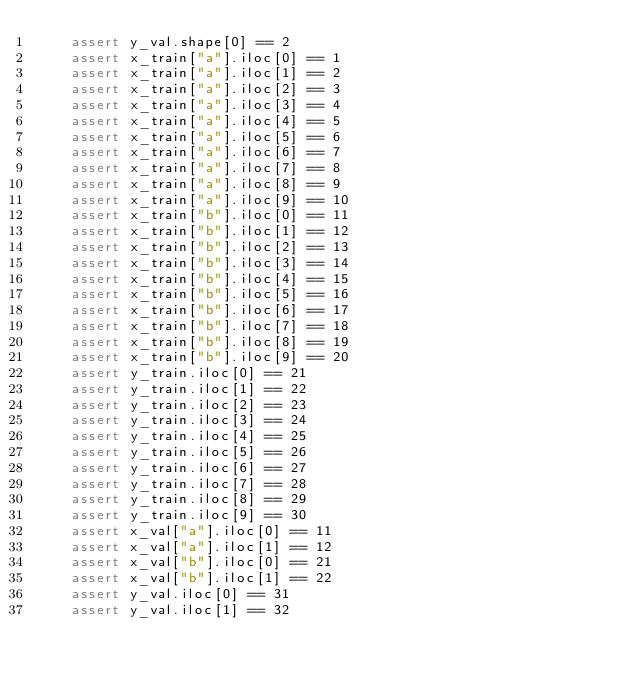<code> <loc_0><loc_0><loc_500><loc_500><_Python_>    assert y_val.shape[0] == 2
    assert x_train["a"].iloc[0] == 1
    assert x_train["a"].iloc[1] == 2
    assert x_train["a"].iloc[2] == 3
    assert x_train["a"].iloc[3] == 4
    assert x_train["a"].iloc[4] == 5
    assert x_train["a"].iloc[5] == 6
    assert x_train["a"].iloc[6] == 7
    assert x_train["a"].iloc[7] == 8
    assert x_train["a"].iloc[8] == 9
    assert x_train["a"].iloc[9] == 10
    assert x_train["b"].iloc[0] == 11
    assert x_train["b"].iloc[1] == 12
    assert x_train["b"].iloc[2] == 13
    assert x_train["b"].iloc[3] == 14
    assert x_train["b"].iloc[4] == 15
    assert x_train["b"].iloc[5] == 16
    assert x_train["b"].iloc[6] == 17
    assert x_train["b"].iloc[7] == 18
    assert x_train["b"].iloc[8] == 19
    assert x_train["b"].iloc[9] == 20
    assert y_train.iloc[0] == 21
    assert y_train.iloc[1] == 22
    assert y_train.iloc[2] == 23
    assert y_train.iloc[3] == 24
    assert y_train.iloc[4] == 25
    assert y_train.iloc[5] == 26
    assert y_train.iloc[6] == 27
    assert y_train.iloc[7] == 28
    assert y_train.iloc[8] == 29
    assert y_train.iloc[9] == 30
    assert x_val["a"].iloc[0] == 11
    assert x_val["a"].iloc[1] == 12
    assert x_val["b"].iloc[0] == 21
    assert x_val["b"].iloc[1] == 22
    assert y_val.iloc[0] == 31
    assert y_val.iloc[1] == 32
</code> 